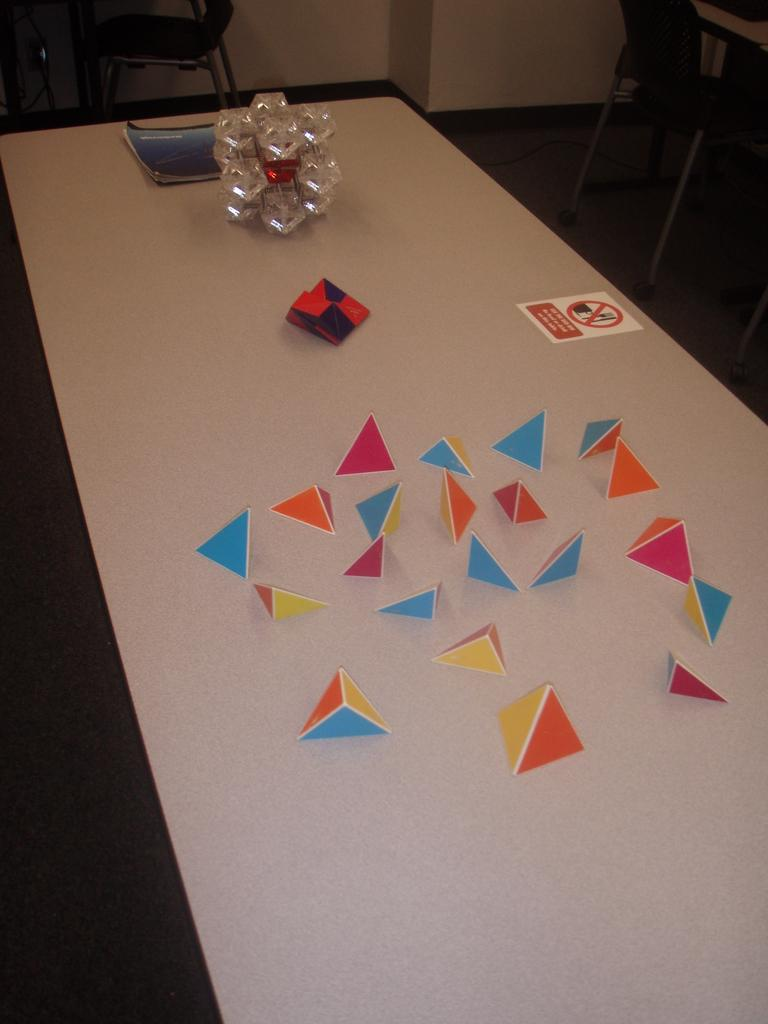What type of furniture is present in the image? There is a table in the image. What is the color of the table? The table is white in color. What can be found on the table? There are objects on the table, including a book. Are there any seating options visible in the image? Yes, there are chairs in the image. What part of the room can be seen in the image? The floor and a wall are visible in the image. What type of scissors is the grandfather using in the image? There is no grandfather or scissors present in the image. What musical instrument is being played in the image? There is no musical instrument being played in the image. 